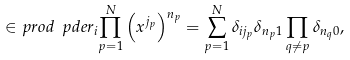<formula> <loc_0><loc_0><loc_500><loc_500>\in p r o d { \ p d e r _ { i } } { \prod _ { p = 1 } ^ { N } \left ( x ^ { j _ { p } } \right ) ^ { n _ { p } } } = \sum _ { p = 1 } ^ { N } \delta _ { i j _ { p } } \delta _ { n _ { p } 1 } \prod _ { q \neq p } \delta _ { n _ { q } 0 } ,</formula> 